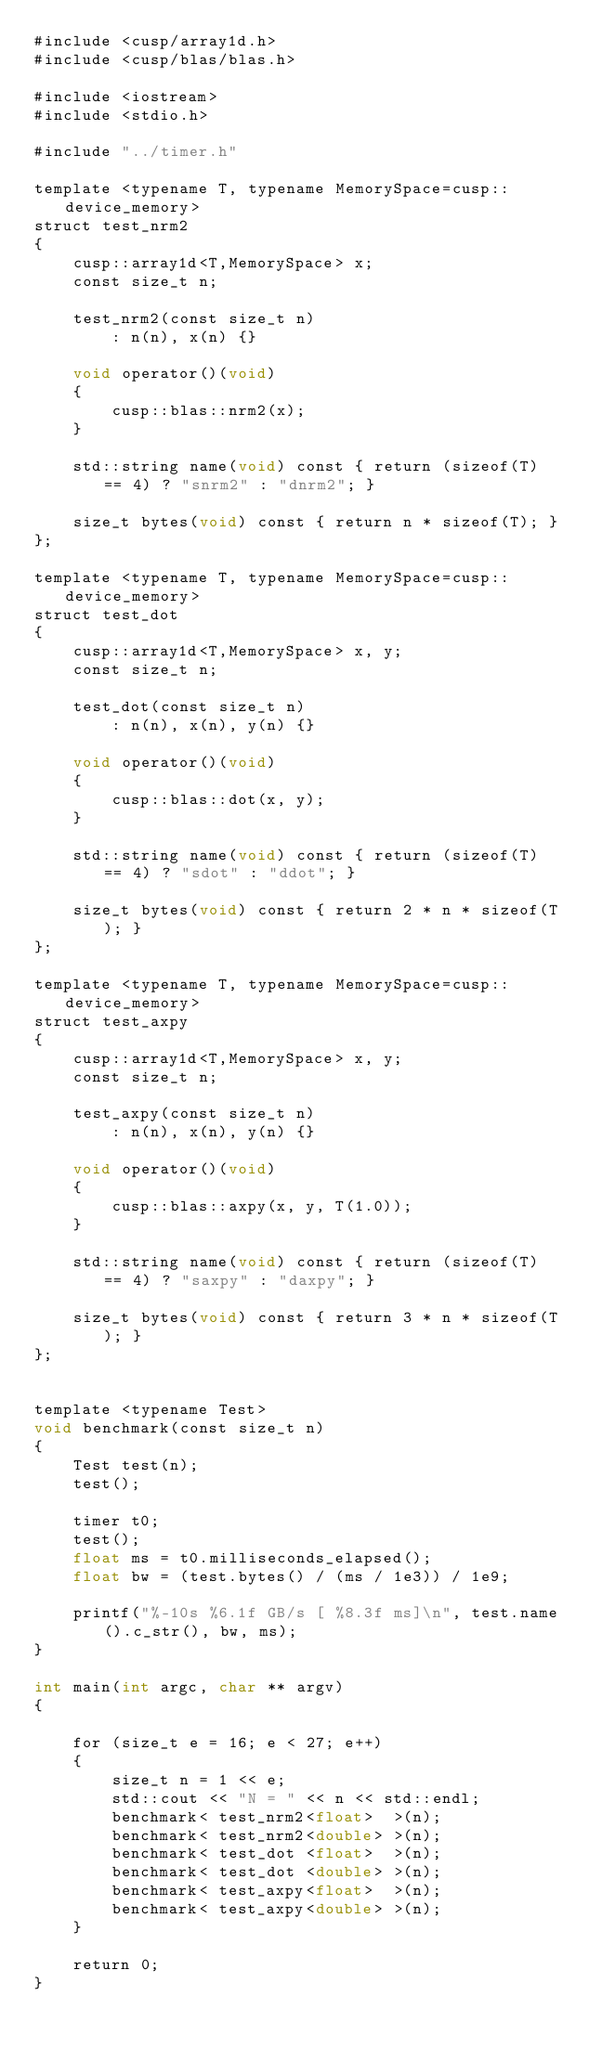<code> <loc_0><loc_0><loc_500><loc_500><_Cuda_>#include <cusp/array1d.h>
#include <cusp/blas/blas.h>

#include <iostream>
#include <stdio.h>

#include "../timer.h"

template <typename T, typename MemorySpace=cusp::device_memory>
struct test_nrm2
{
    cusp::array1d<T,MemorySpace> x;
    const size_t n;

    test_nrm2(const size_t n)
        : n(n), x(n) {}

    void operator()(void)
    {
        cusp::blas::nrm2(x);
    }

    std::string name(void) const { return (sizeof(T) == 4) ? "snrm2" : "dnrm2"; }

    size_t bytes(void) const { return n * sizeof(T); }
};

template <typename T, typename MemorySpace=cusp::device_memory>
struct test_dot
{
    cusp::array1d<T,MemorySpace> x, y;
    const size_t n;

    test_dot(const size_t n)
        : n(n), x(n), y(n) {}

    void operator()(void)
    {
        cusp::blas::dot(x, y);
    }

    std::string name(void) const { return (sizeof(T) == 4) ? "sdot" : "ddot"; }

    size_t bytes(void) const { return 2 * n * sizeof(T); }
};

template <typename T, typename MemorySpace=cusp::device_memory>
struct test_axpy
{
    cusp::array1d<T,MemorySpace> x, y;
    const size_t n;

    test_axpy(const size_t n)
        : n(n), x(n), y(n) {}

    void operator()(void)
    {
        cusp::blas::axpy(x, y, T(1.0));
    }

    std::string name(void) const { return (sizeof(T) == 4) ? "saxpy" : "daxpy"; }

    size_t bytes(void) const { return 3 * n * sizeof(T); }
};


template <typename Test>
void benchmark(const size_t n)
{
    Test test(n);
    test();

    timer t0;
    test();
    float ms = t0.milliseconds_elapsed();
    float bw = (test.bytes() / (ms / 1e3)) / 1e9;

    printf("%-10s %6.1f GB/s [ %8.3f ms]\n", test.name().c_str(), bw, ms);
}

int main(int argc, char ** argv)
{

    for (size_t e = 16; e < 27; e++)
    {
        size_t n = 1 << e;
        std::cout << "N = " << n << std::endl;
        benchmark< test_nrm2<float>  >(n);
        benchmark< test_nrm2<double> >(n);
        benchmark< test_dot <float>  >(n);
        benchmark< test_dot <double> >(n);
        benchmark< test_axpy<float>  >(n);
        benchmark< test_axpy<double> >(n);
    }

    return 0;
}

</code> 